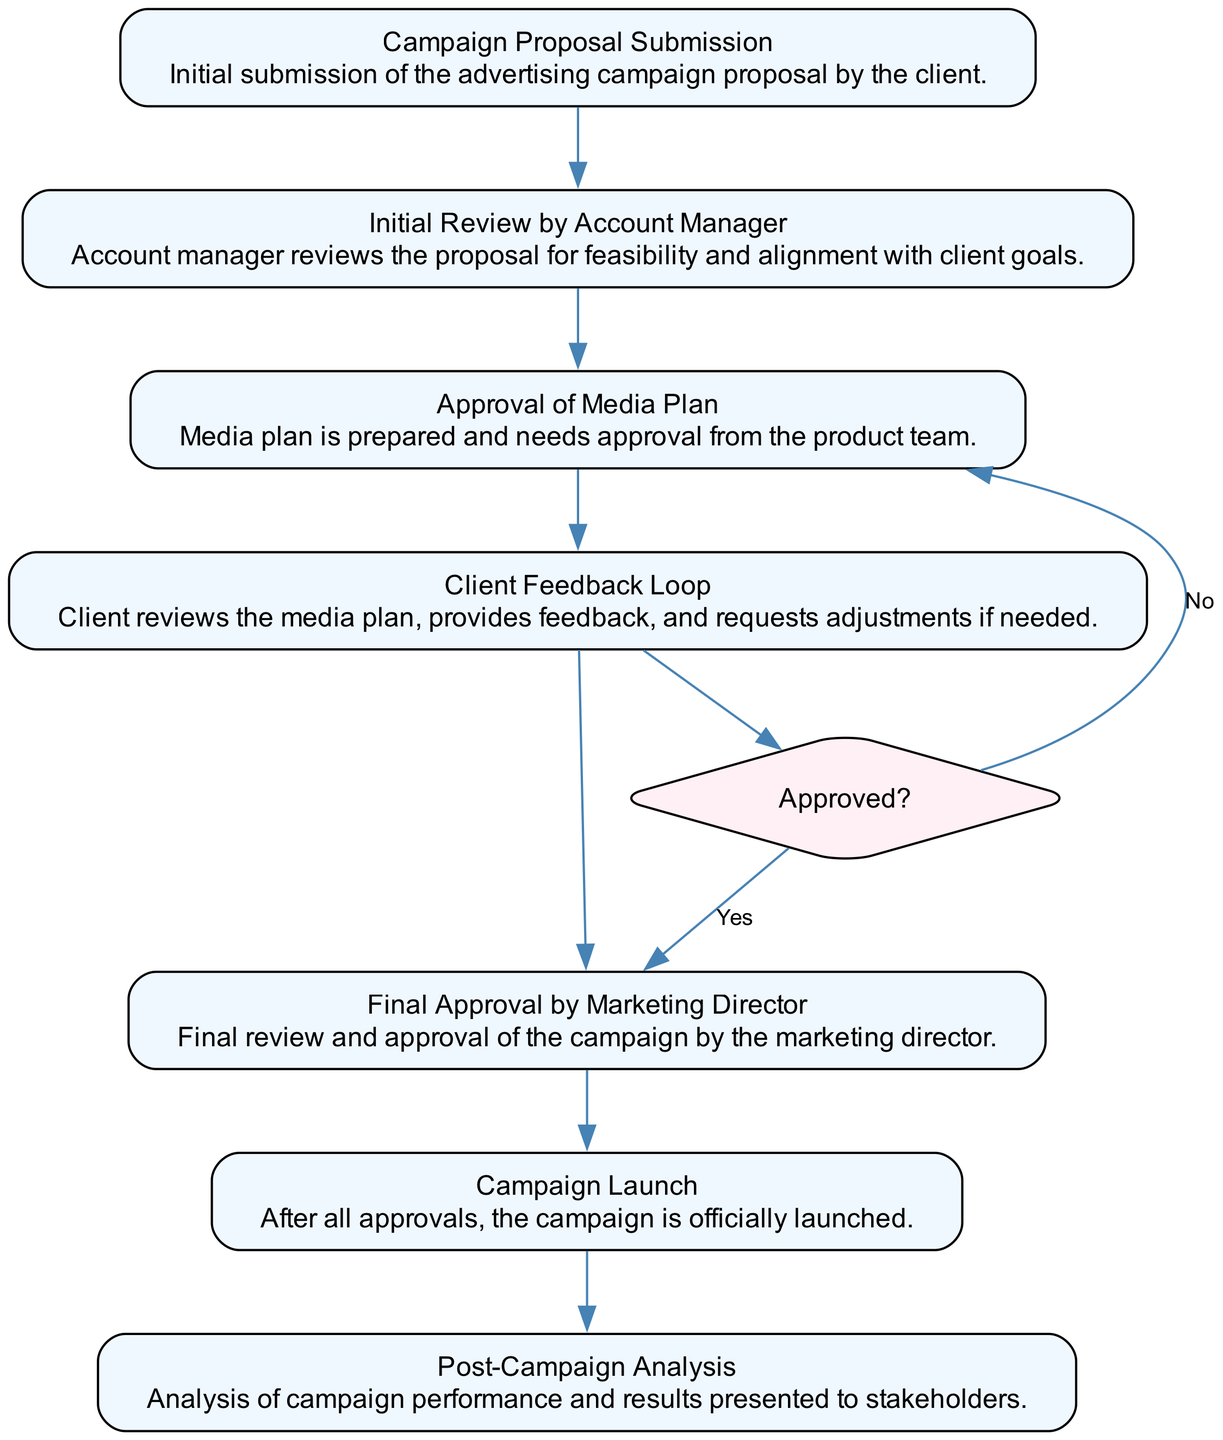What is the first step in the advertising campaign approval process? The first step in the diagram is "Campaign Proposal Submission," which indicates the initial action taken by the client.
Answer: Campaign Proposal Submission How many main steps are there in the approval process before the campaign is launched? The diagram outlines six main steps before reaching the "Campaign Launch," which counts all the listed elements except for the post-campaign analysis.
Answer: six What happens after the "Client Feedback Loop" if the feedback is approved? If the feedback from the "Client Feedback Loop" is approved, the flow moves to the "Final Approval by Marketing Director."
Answer: Final Approval by Marketing Director What decision is made after the "Client Feedback Loop"? After the "Client Feedback Loop," a decision is made if the proposals are "Approved?" indicating a review process is needed before proceeding.
Answer: Approved? If the media plan is not approved after client feedback, which step should be revisited? If the media plan is not approved, the process returns to the "Initial Review by Account Manager," reflecting that adjustments need to be reconsidered.
Answer: Initial Review by Account Manager What is the purpose of the "Post-Campaign Analysis"? The "Post-Campaign Analysis" serves to evaluate the performance and results of the advertising campaign and present findings to stakeholders, indicating its evaluative purpose.
Answer: Analysis of campaign performance Which node represents the final action in the diagram? The "Campaign Launch" represents the final action, indicating the execution of the approved campaign.
Answer: Campaign Launch How many decision nodes are present in the diagram? The diagram includes only one decision node, labeled "Approved?" which influences the workflow depending on approval feedback.
Answer: one 